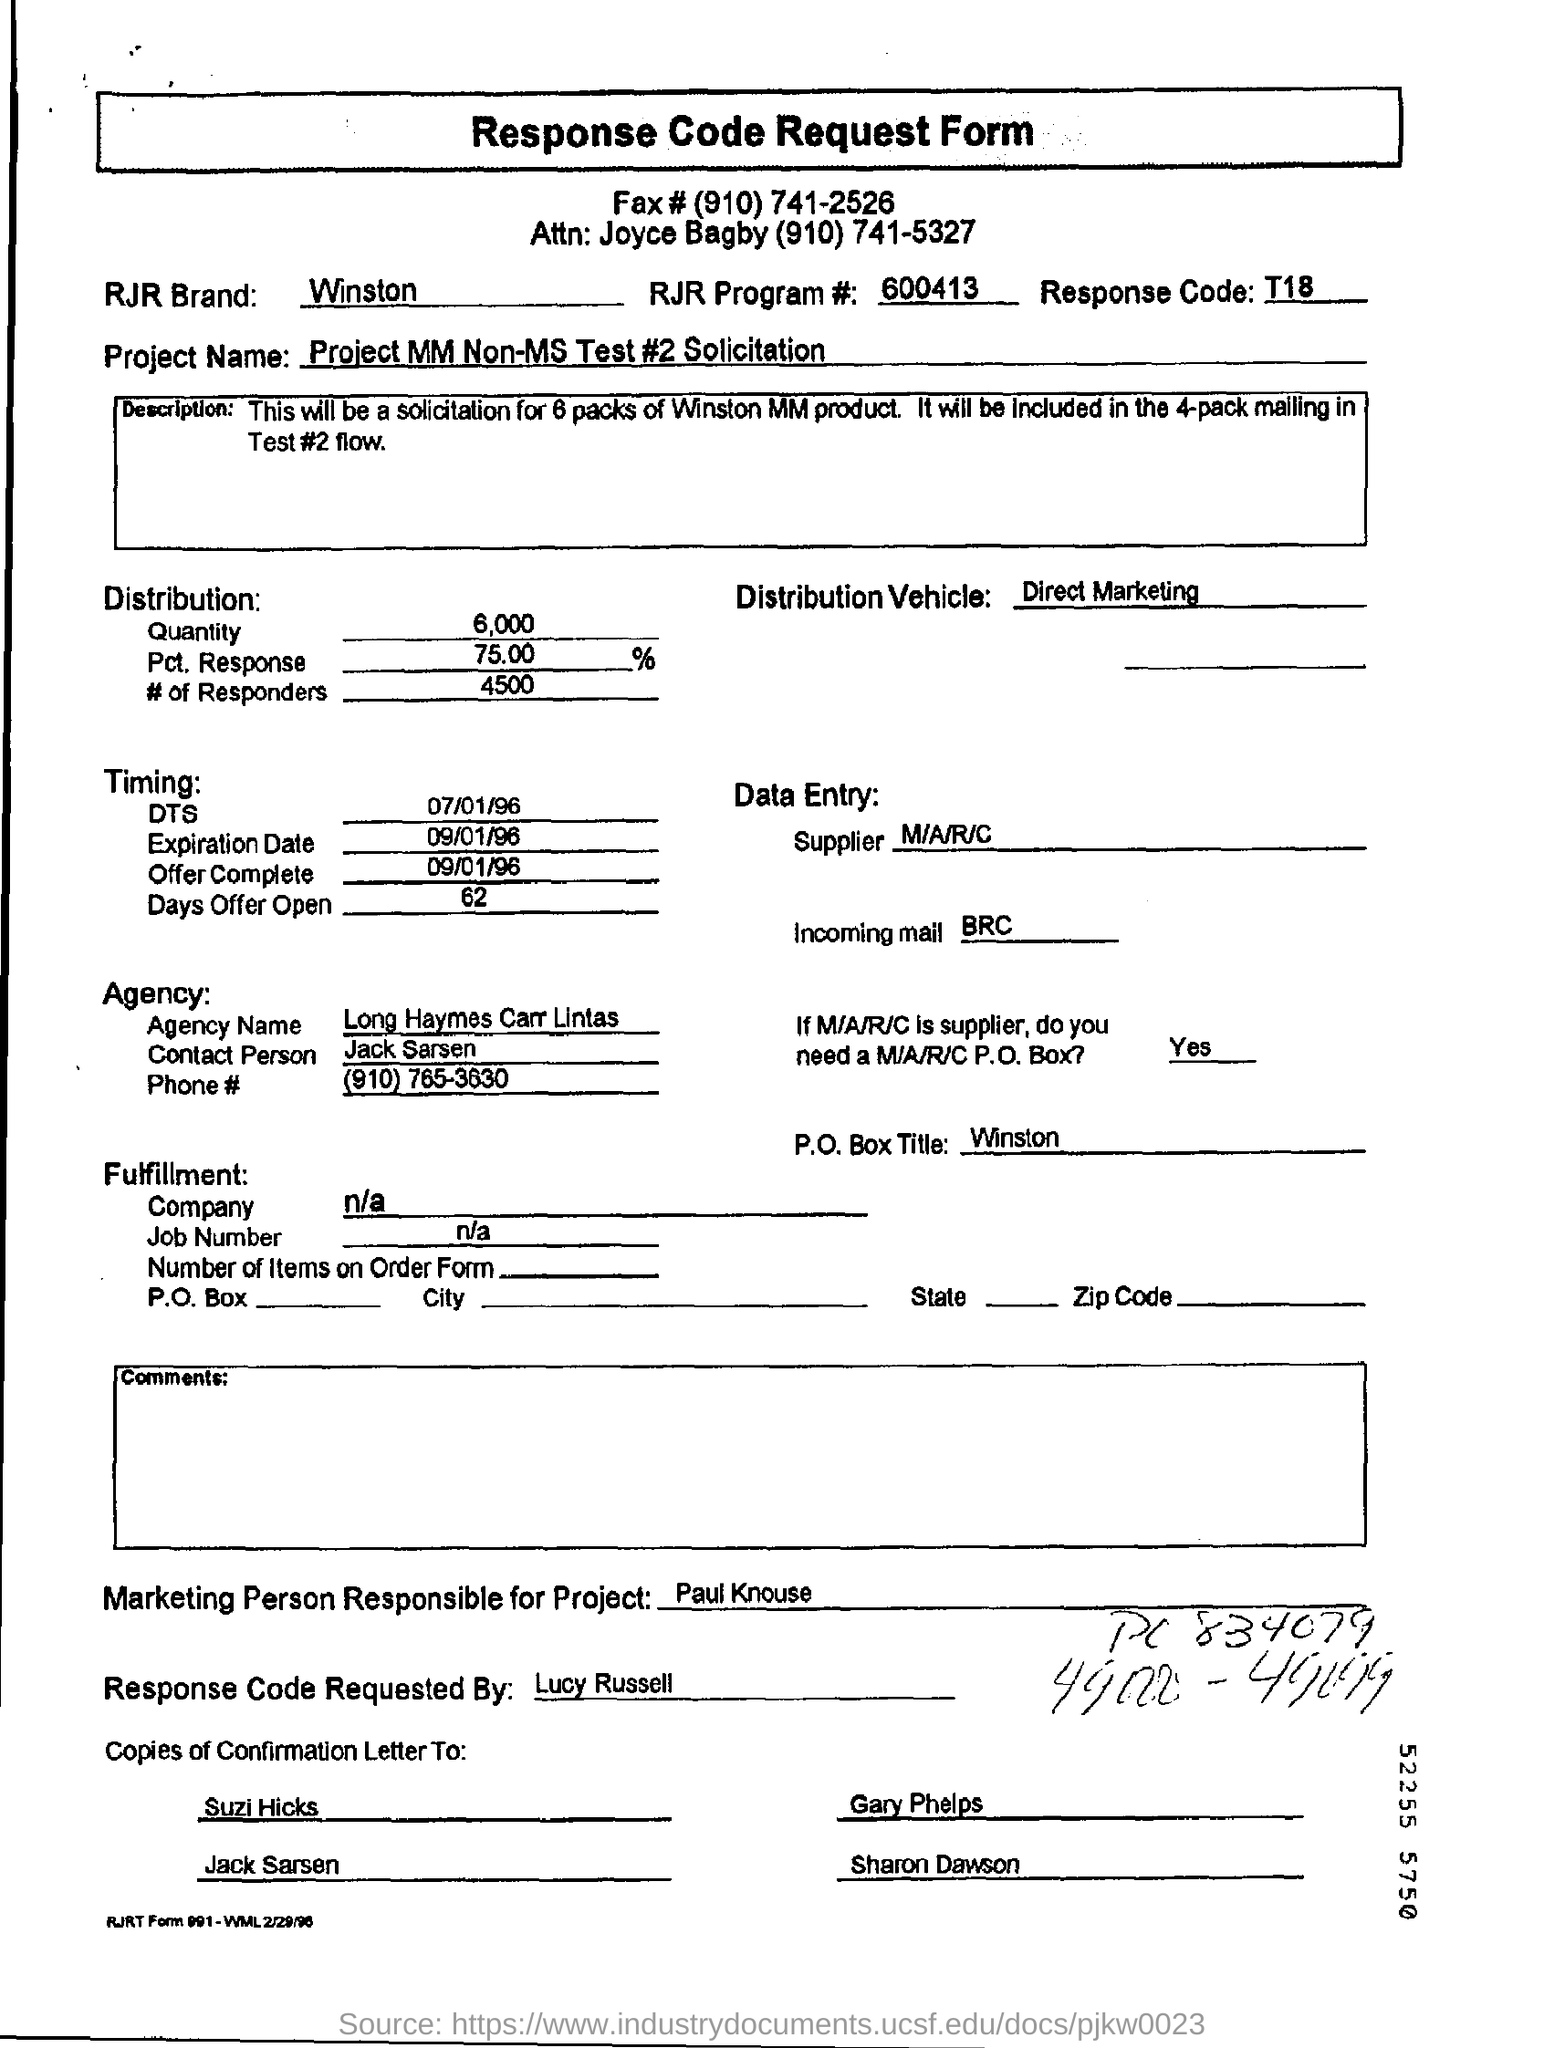What is the Fax number given?
Provide a succinct answer. (910) 741-2526. Which is the RJR Brand?
Provide a succinct answer. Winston. What is the RJR Program number?
Offer a terse response. 600413. What is the Response Code?
Your answer should be very brief. T18. What is the project name mentioned in the form?
Your response must be concise. Project MM Non-MS Test #2 Solicitation. What is the name of the agency?
Make the answer very short. Long Haymes Carr Lintas. 